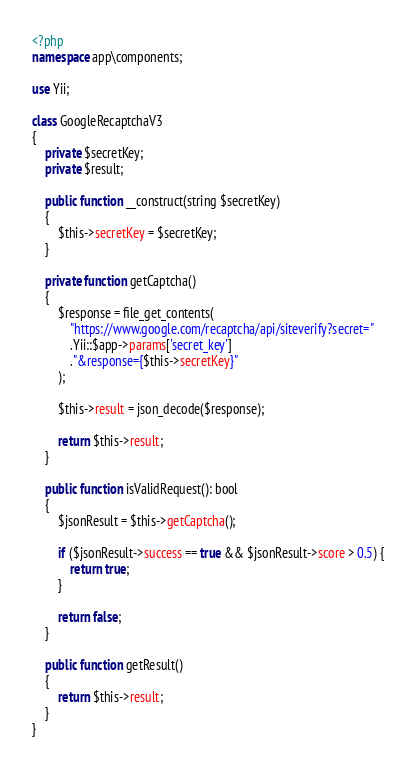<code> <loc_0><loc_0><loc_500><loc_500><_PHP_><?php
namespace app\components;

use Yii;

class GoogleRecaptchaV3
{
    private $secretKey;
    private $result;

    public function __construct(string $secretKey)
    {
        $this->secretKey = $secretKey;
    }

    private function getCaptcha()
    {
        $response = file_get_contents(
            "https://www.google.com/recaptcha/api/siteverify?secret="
            .Yii::$app->params['secret_key']
            ."&response={$this->secretKey}"
        );

        $this->result = json_decode($response);

        return $this->result;
    }

    public function isValidRequest(): bool
    {
        $jsonResult = $this->getCaptcha();

        if ($jsonResult->success == true && $jsonResult->score > 0.5) {
            return true;
        }

        return false;
    }

    public function getResult()
    {
        return $this->result;
    }
}</code> 